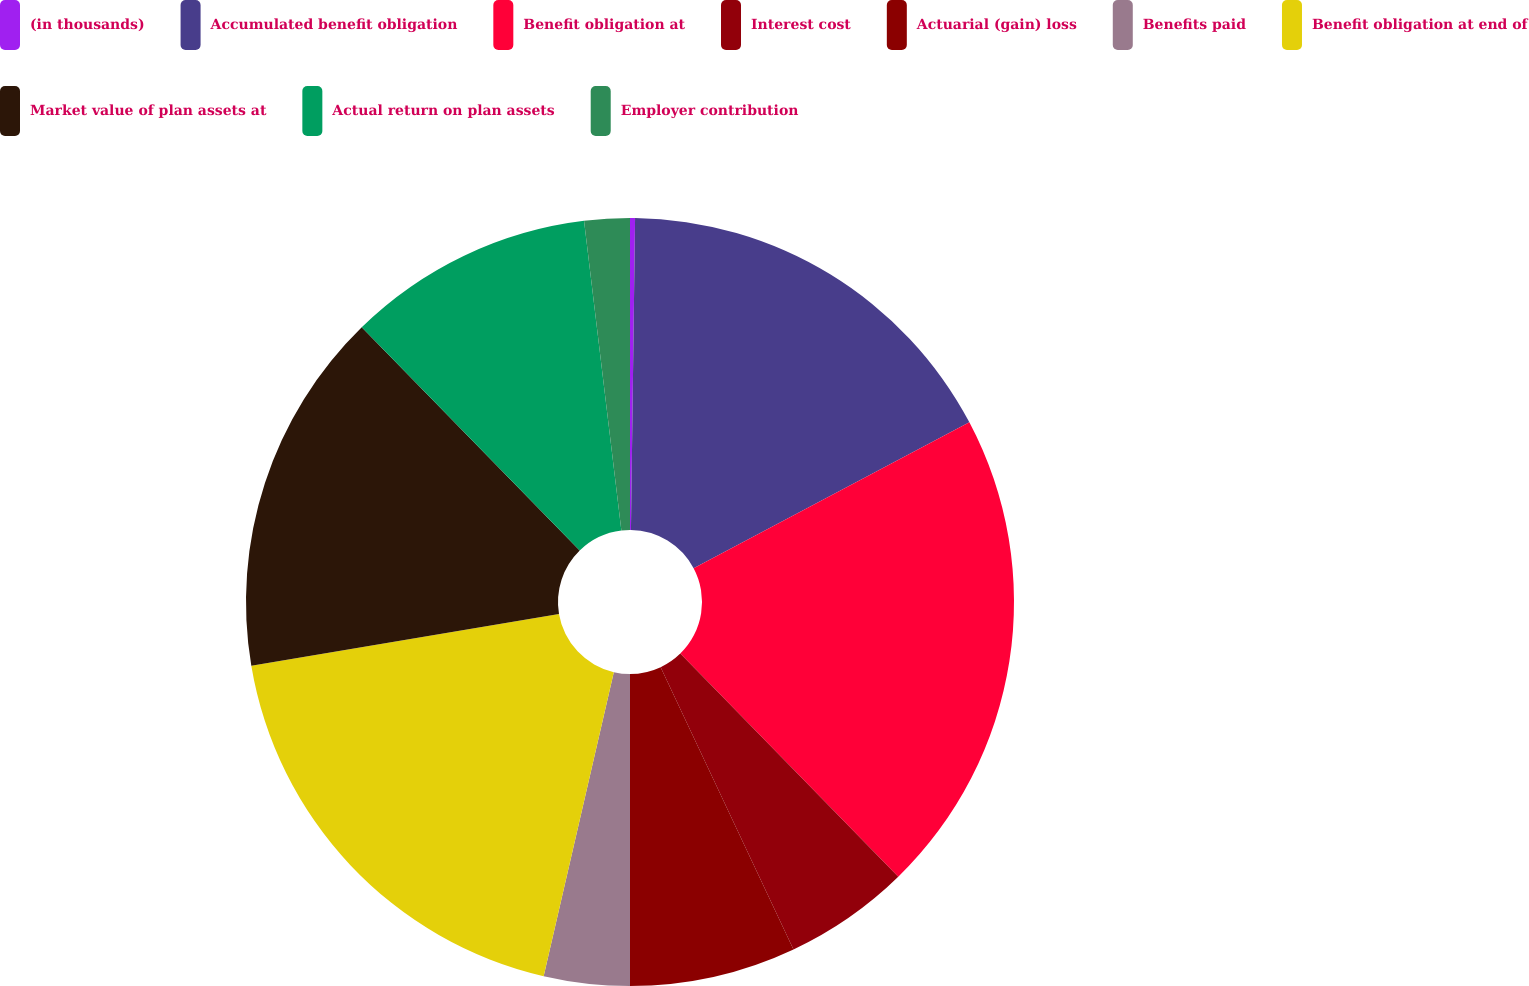Convert chart to OTSL. <chart><loc_0><loc_0><loc_500><loc_500><pie_chart><fcel>(in thousands)<fcel>Accumulated benefit obligation<fcel>Benefit obligation at<fcel>Interest cost<fcel>Actuarial (gain) loss<fcel>Benefits paid<fcel>Benefit obligation at end of<fcel>Market value of plan assets at<fcel>Actual return on plan assets<fcel>Employer contribution<nl><fcel>0.21%<fcel>17.04%<fcel>20.44%<fcel>5.31%<fcel>7.0%<fcel>3.61%<fcel>18.74%<fcel>15.34%<fcel>10.4%<fcel>1.91%<nl></chart> 